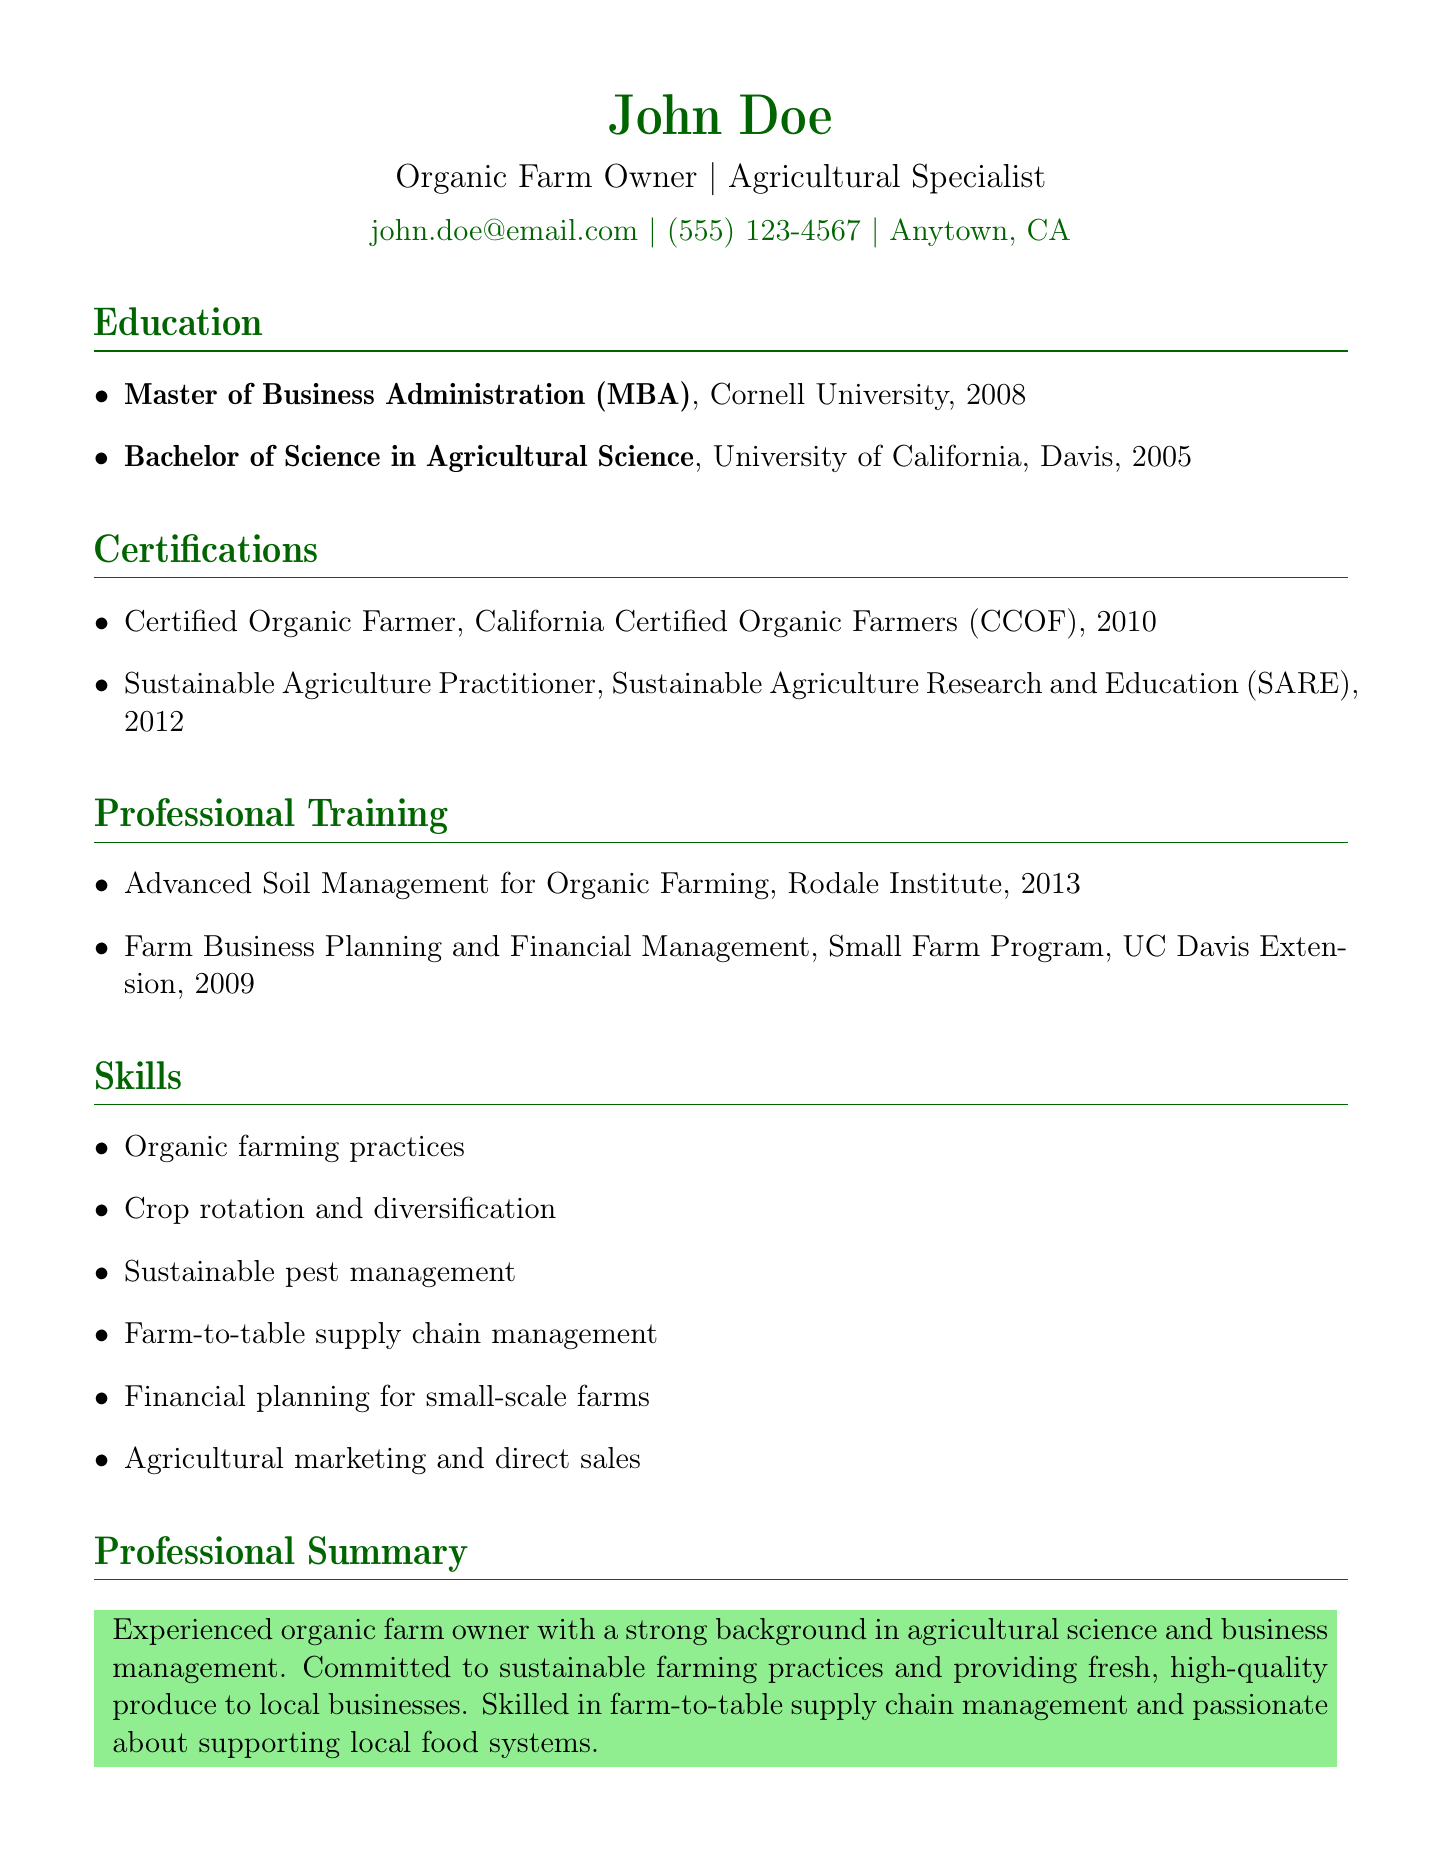what degree did John Doe earn from Cornell University? The document states that John Doe earned a Master of Business Administration (MBA) from Cornell University.
Answer: Master of Business Administration (MBA) what year did John Doe obtain his Bachelor of Science in Agricultural Science? The document indicates that John Doe obtained his Bachelor of Science in Agricultural Science in 2005.
Answer: 2005 who issued the Certified Organic Farmer certification? The document mentions that the Certified Organic Farmer certification was issued by California Certified Organic Farmers (CCOF).
Answer: California Certified Organic Farmers (CCOF) which institution provided the training on Farm Business Planning and Financial Management? The document specifies that the training for Farm Business Planning and Financial Management was provided by the Small Farm Program, UC Davis Extension.
Answer: Small Farm Program, UC Davis Extension how many years after his Bachelor's degree did John Doe earn his MBA? The document shows that John Doe completed his Bachelor's degree in 2005 and his MBA in 2008, indicating he earned it three years later.
Answer: 3 years what is one of the skills listed for John Doe related to pest management? The document lists "Sustainable pest management" as one of John Doe's skills.
Answer: Sustainable pest management in what year did John Doe complete the Advanced Soil Management for Organic Farming course? According to the document, John Doe completed the Advanced Soil Management for Organic Farming course in 2013.
Answer: 2013 what is the main focus of John Doe as described in the Professional Summary? The Professional Summary states that John Doe is committed to sustainable farming practices.
Answer: Sustainable farming practices what type of certifications does John Doe have? The document states that John Doe has certifications related to organic farming and sustainable agriculture.
Answer: Organic farming and sustainable agriculture 